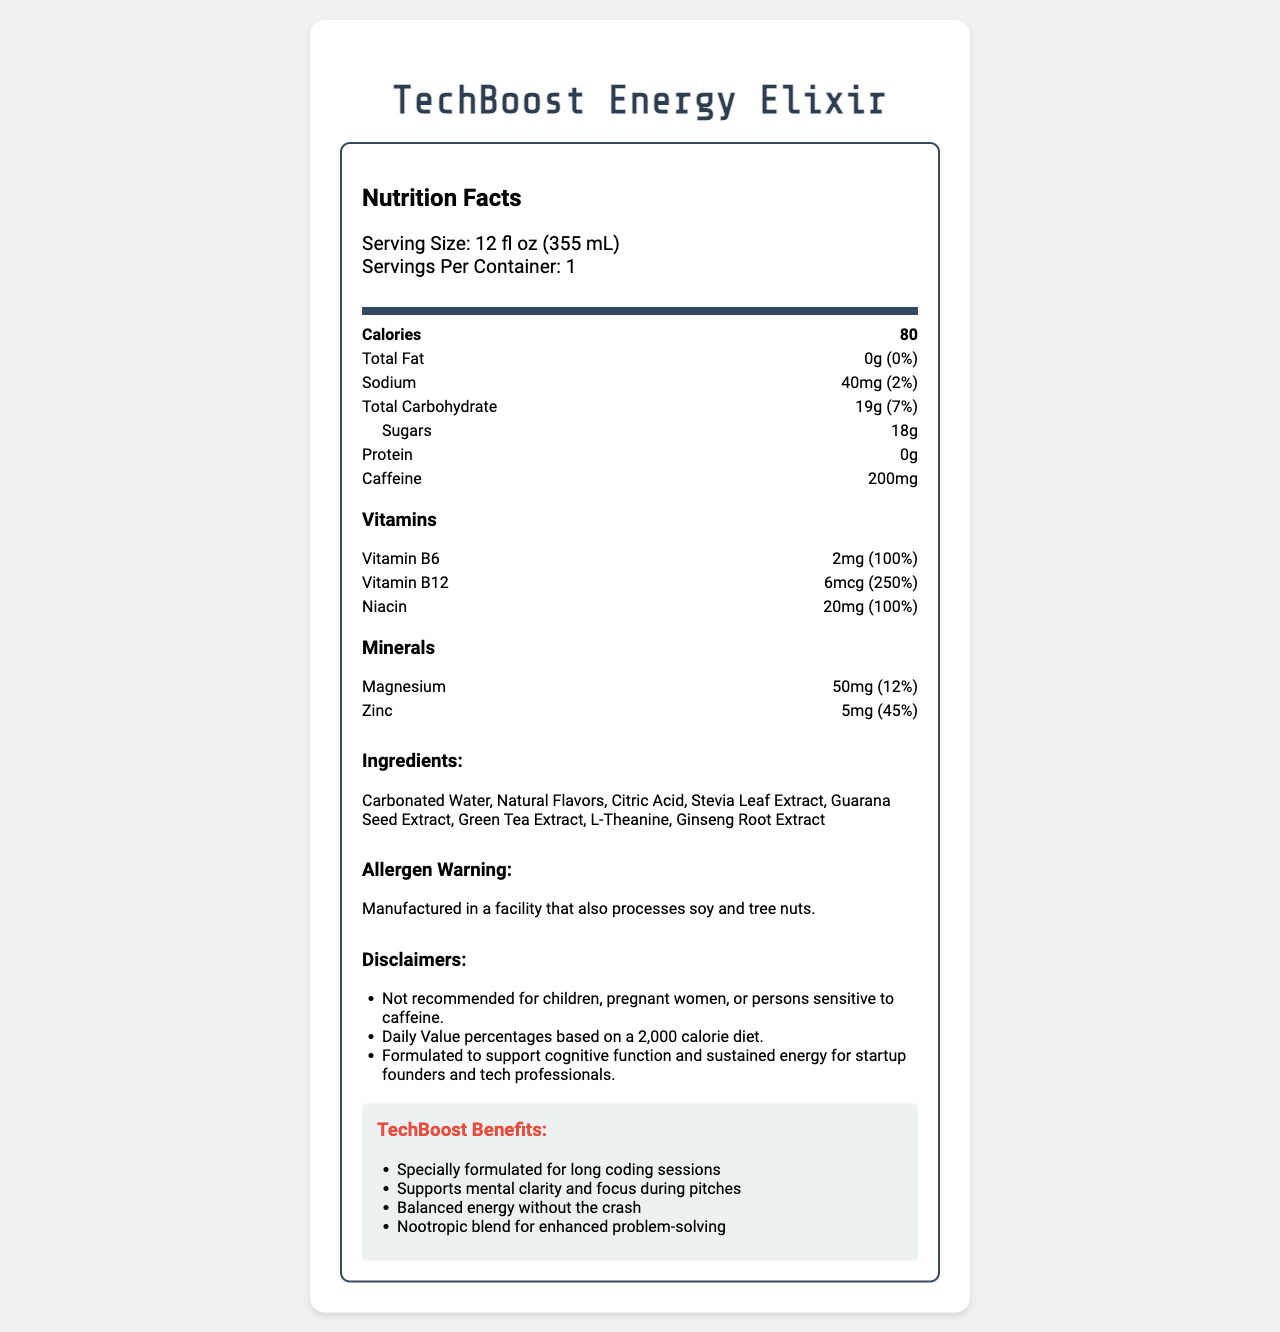what is the serving size for TechBoost Energy Elixir? The serving size is clearly stated under the nutrition facts section as "Serving Size: 12 fl oz (355 mL)".
Answer: 12 fl oz (355 mL) how many calories are in one serving of the drink? The calories per serving are shown in the nutrition facts section as "Calories: 80".
Answer: 80 what is the caffeine content per serving? The amount of caffeine per serving is listed in the nutrition facts section as "Caffeine: 200mg".
Answer: 200mg how much sodium does the drink contain per serving? The sodium content per serving is listed as "Sodium: 40mg" in the nutrition facts section.
Answer: 40mg does TechBoost Energy Elixir contain any protein? The document lists "Protein: 0g" in the nutrition facts section, indicating there is no protein in the drink.
Answer: No which vitamin has the highest percent daily value in the drink? A. Vitamin B6 B. Vitamin B12 C. Niacin D. Magnesium The percent daily value for Vitamin B12 is 250%, which is higher than Vitamin B6 (100%), Niacin (100%), and Magnesium (12%).
Answer: B what is the total carbohydrate content per serving, and what percent of the daily value does it represent? The document states that the total carbohydrate content is "19g" and represents "7%" of the daily value.
Answer: 19g, 7% is the TechBoost Energy Elixir recommended for children and pregnant women? According to the disclaimers section: "Not recommended for children, pregnant women, or persons sensitive to caffeine."
Answer: No what are the key benefits mentioned in the marketing claims section? In the marketing claims section, the drink is described as "Specially formulated for long coding sessions", "Supports mental clarity and focus during pitches", "Balanced energy without the crash", and includes a "Nootropic blend for enhanced problem-solving".
Answer: Specially formulated for long coding sessions, Supports mental clarity and focus during pitches, Balanced energy without the crash, Nootropic blend for enhanced problem-solving does the drink contain any allergenic ingredients? The document does not state that the drink contains allergenic ingredients, but it does include an allergen warning: "Manufactured in a facility that also processes soy and tree nuts."
Answer: No how much zinc is in the TechBoost Energy Elixir, and what percentage of the daily value does it provide? The mineral section indicates that zinc is present in the amount of "5mg" which corresponds to "45%" of the daily value.
Answer: 5mg, 45% what ingredients are used in the TechBoost Energy Elixir? The ingredients section of the document lists all of these components as part of the drink's composition.
Answer: Carbonated Water, Natural Flavors, Citric Acid, Stevia Leaf Extract, Guarana Seed Extract, Green Tea Extract, L-Theanine, Ginseng Root Extract what is the main idea of the nutrition facts document for TechBoost Energy Elixir? The document is primarily focused on presenting the nutritional content and benefits of TechBoost Energy Elixir. It underscores the specific nutrients present in the drink while also offering marketing claims about its benefits for sustained energy and mental clarity, targeting startup founders. Additionally, the document includes necessary disclaimers and an allergen warning.
Answer: The document provides detailed nutritional information about TechBoost Energy Elixir, an energy drink designed for startup founders, highlighting its low-calorie content, high caffeine levels, and various vitamins and minerals aimed at supporting mental clarity and sustained energy. It also includes disclaimers and allergen warnings. is TechBoost Energy Elixir suitable for someone on a low-sodium diet? With only 40mg of sodium per serving, which amounts to 2% of the daily value, the sodium content is quite low, making it relatively suitable for a low-sodium diet, although the final suitability might depend on overall daily intake.
Answer: Yes, it is relatively suitable. how does the TechBoost Energy Elixir support mental clarity and focus? The marketing claims emphasize mental clarity and focus during pitches, supported by ingredients known to have cognitive benefits, including L-Theanine, Ginseng Root Extract, and a high percentage of Vitamin B12.
Answer: Through a blend of nootropic ingredients, such as L-Theanine, Ginseng Root Extract, and high levels of Vitamin B12. what is the combined amount of vitamins B6 and B12 in the drink? The vitamins section lists these vitamins separately: "Vitamin B6: 2mg (100%)" and "Vitamin B12: 6mcg (250%)".
Answer: 2mg of Vitamin B6 and 6mcg of Vitamin B12 how many grams of sugars does the TechBoost Energy Elixir contain? The document specifies that the drink contains "Sugars: 18g" per serving.
Answer: 18g which statement is not mentioned in the marketing claims section? A. Enhances physical endurance B. Specially formulated for long coding sessions C. Supports mental clarity and focus during pitches D. Balanced energy without the crash The statement "Enhances physical endurance" is not included in the marketing claims section.
Answer: A what is the percent daily value of magnesium in the drink? The minerals section lists the magnesium content as 50mg, which corresponds to 12% of the daily value.
Answer: 12% how does the drink claim to offer balanced energy without crashing? According to the marketing claims, the drink provides "Balanced energy without the crash" due to its formulation. Ingredients like L-Theanine and natural extracts are likely responsible for these effects.
Answer: The specific formulation with ingredients like L-Theanine and natural extracts helps in providing sustained energy without the usual crash associated with energy drinks. what is the main source of sweetness in the drink? Among the ingredients listed, Stevia Leaf Extract is known for being a natural sweetener, suggesting it is the main source of sweetness in the drink.
Answer: Stevia Leaf Extract what other products are manufactured in the same facility as TechBoost Energy Elixir? The document only mentions an allergen warning: "Manufactured in a facility that also processes soy and tree nuts," but does not specify what other products are made in the same facility.
Answer: Cannot be determined 